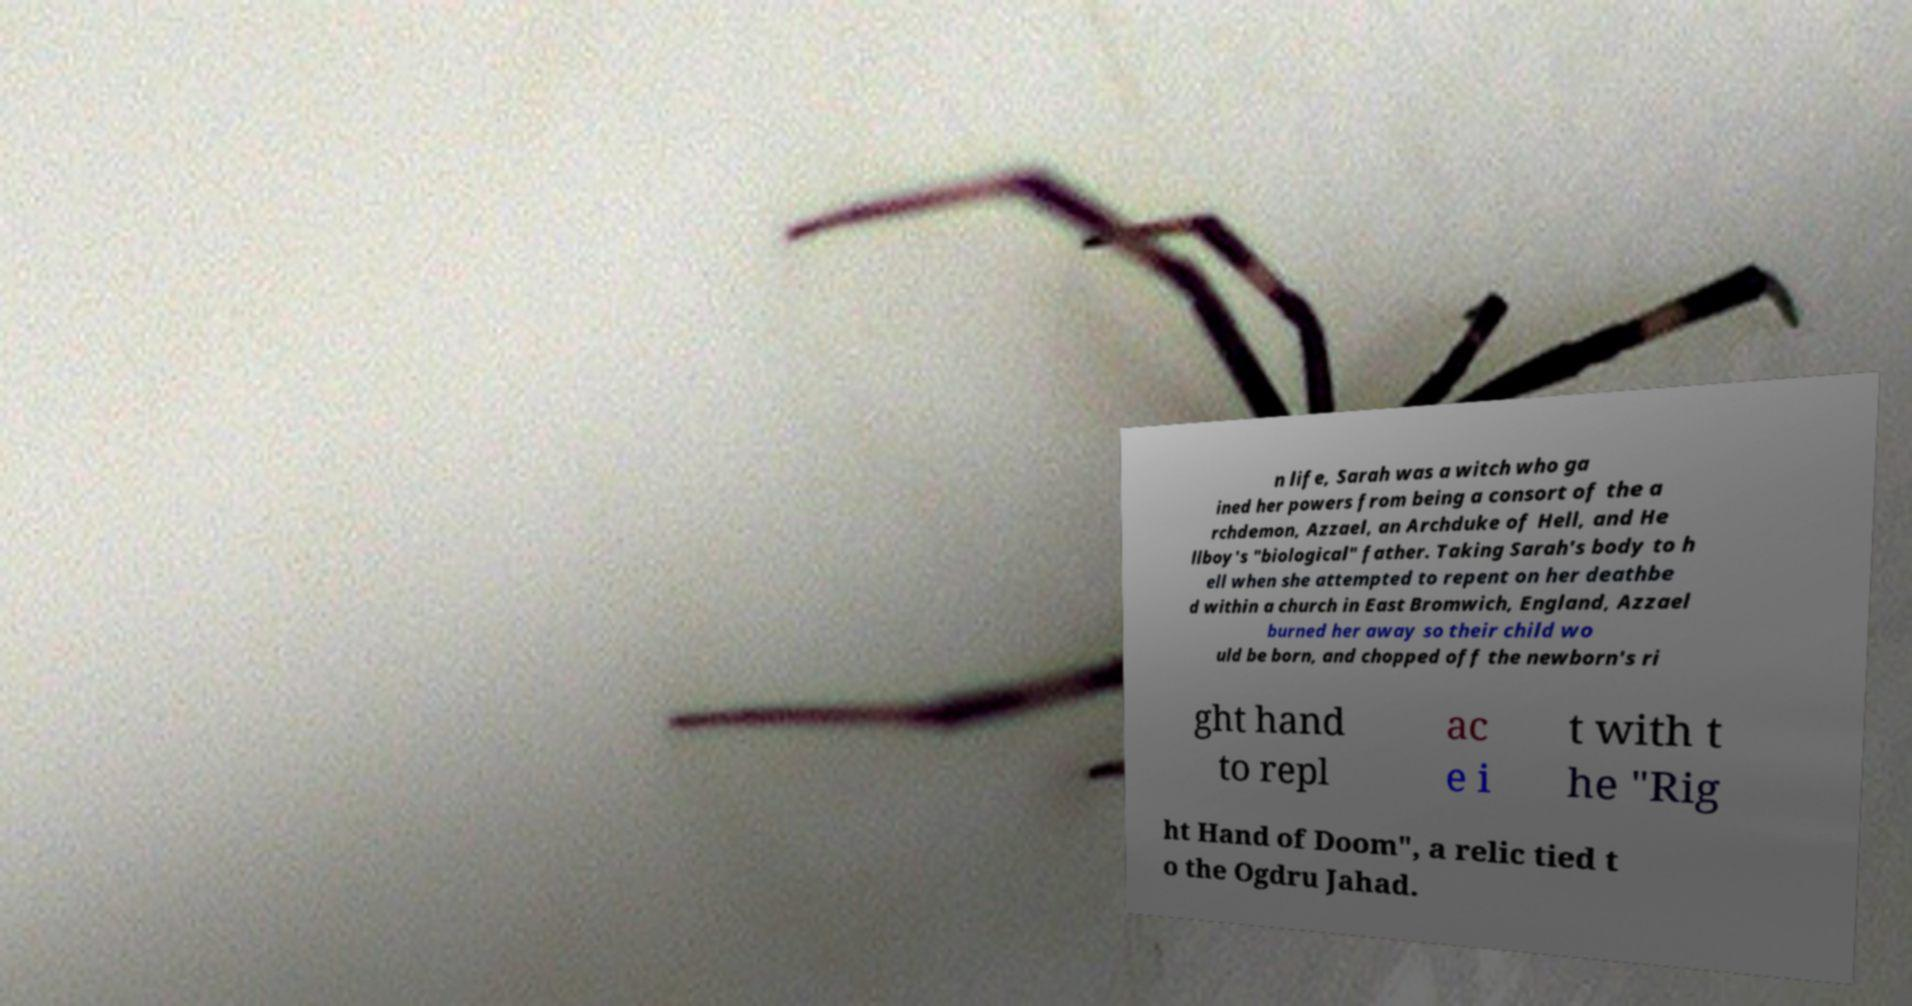Could you assist in decoding the text presented in this image and type it out clearly? n life, Sarah was a witch who ga ined her powers from being a consort of the a rchdemon, Azzael, an Archduke of Hell, and He llboy's "biological" father. Taking Sarah's body to h ell when she attempted to repent on her deathbe d within a church in East Bromwich, England, Azzael burned her away so their child wo uld be born, and chopped off the newborn's ri ght hand to repl ac e i t with t he "Rig ht Hand of Doom", a relic tied t o the Ogdru Jahad. 